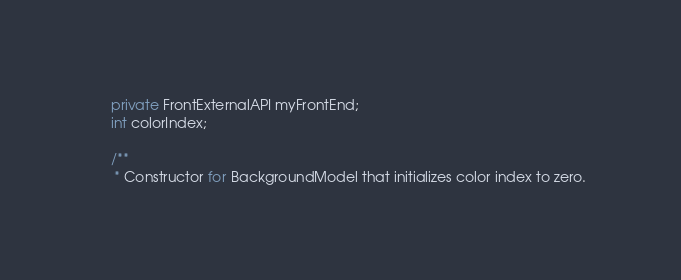<code> <loc_0><loc_0><loc_500><loc_500><_Java_>    private FrontExternalAPI myFrontEnd;
    int colorIndex;

    /**
     * Constructor for BackgroundModel that initializes color index to zero.</code> 